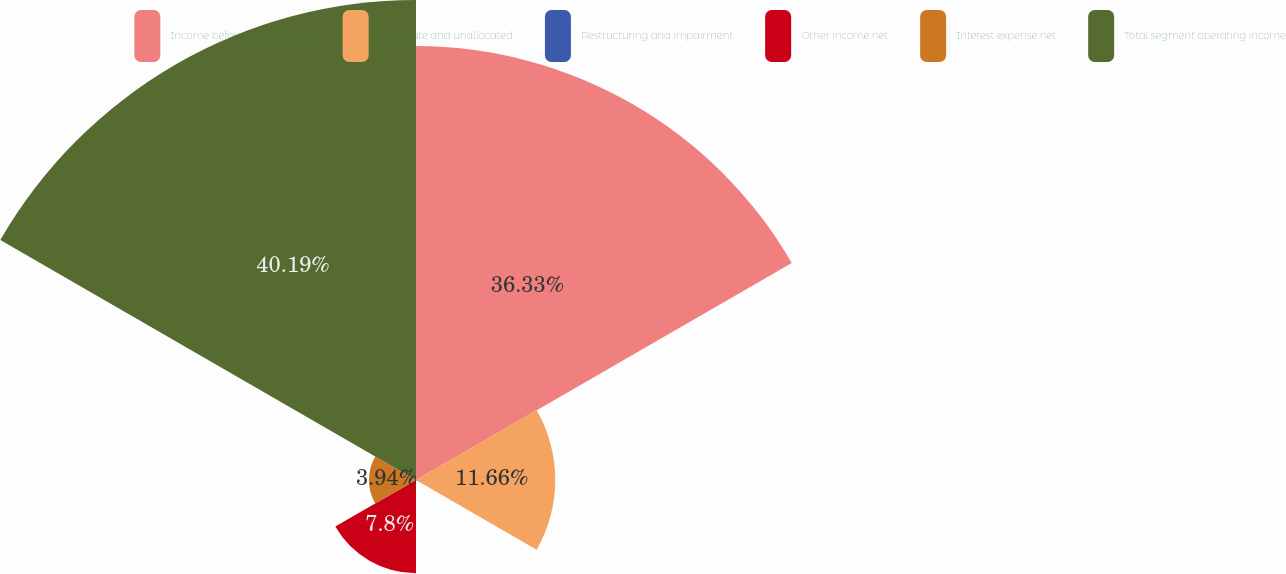<chart> <loc_0><loc_0><loc_500><loc_500><pie_chart><fcel>Income before income taxes<fcel>Corporate and unallocated<fcel>Restructuring and impairment<fcel>Other income net<fcel>Interest expense net<fcel>Total segment operating income<nl><fcel>36.32%<fcel>11.66%<fcel>0.08%<fcel>7.8%<fcel>3.94%<fcel>40.18%<nl></chart> 